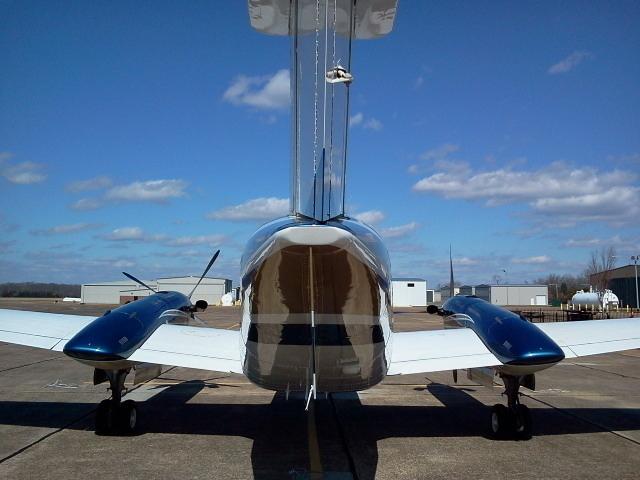What is the color scheme of the plane?
Write a very short answer. Blue and white. How many people can fit inside the plane?
Short answer required. 2. Is this a plane race?
Write a very short answer. No. 